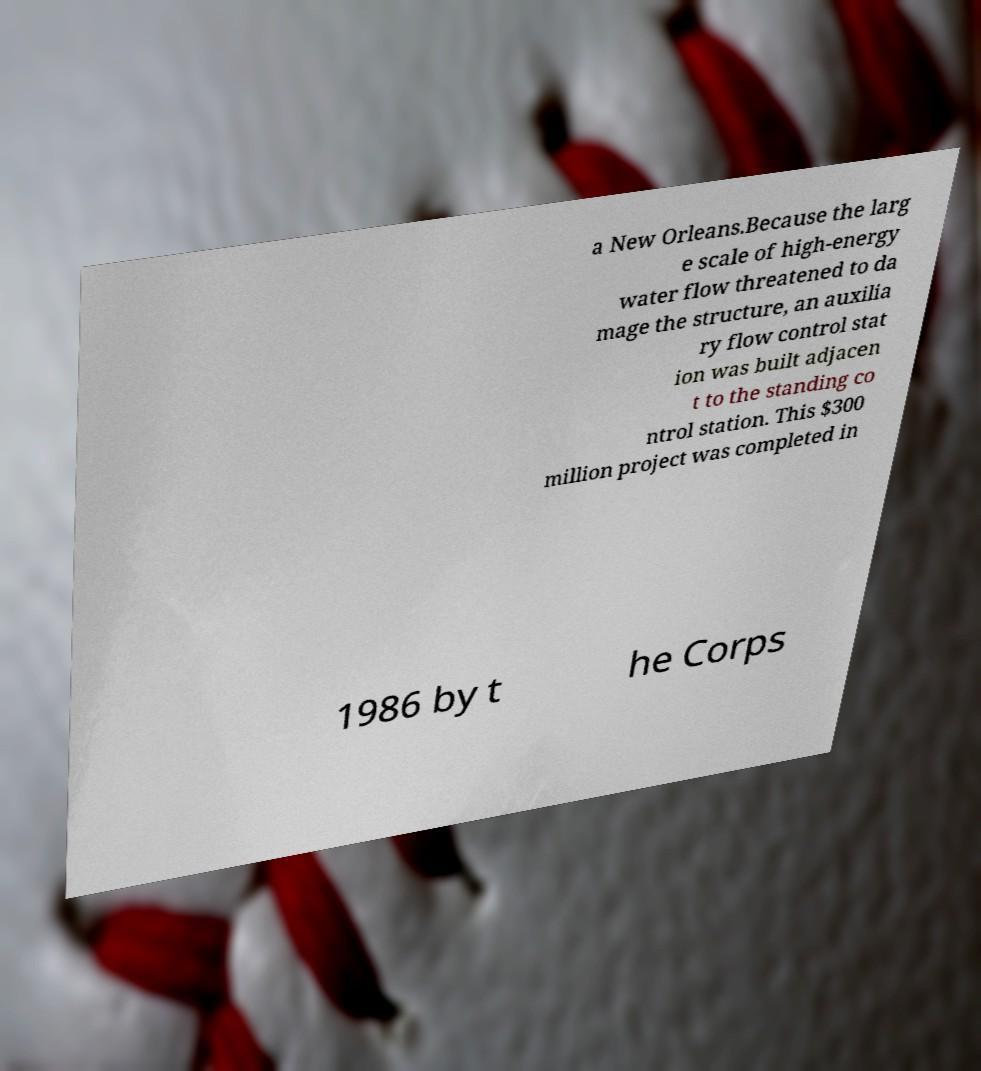Could you assist in decoding the text presented in this image and type it out clearly? a New Orleans.Because the larg e scale of high-energy water flow threatened to da mage the structure, an auxilia ry flow control stat ion was built adjacen t to the standing co ntrol station. This $300 million project was completed in 1986 by t he Corps 